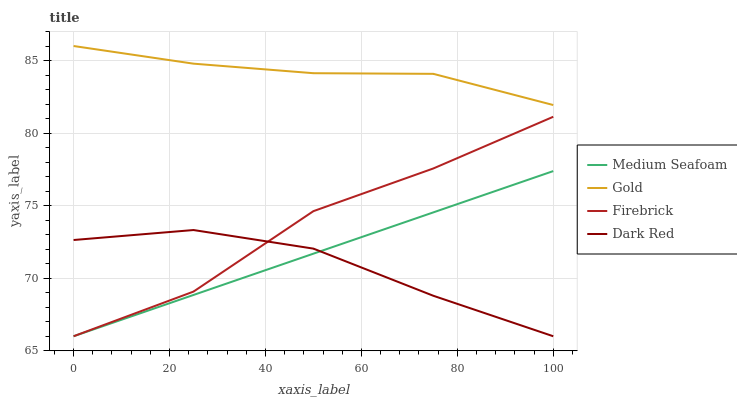Does Dark Red have the minimum area under the curve?
Answer yes or no. Yes. Does Gold have the maximum area under the curve?
Answer yes or no. Yes. Does Firebrick have the minimum area under the curve?
Answer yes or no. No. Does Firebrick have the maximum area under the curve?
Answer yes or no. No. Is Medium Seafoam the smoothest?
Answer yes or no. Yes. Is Firebrick the roughest?
Answer yes or no. Yes. Is Firebrick the smoothest?
Answer yes or no. No. Is Medium Seafoam the roughest?
Answer yes or no. No. Does Dark Red have the lowest value?
Answer yes or no. Yes. Does Gold have the lowest value?
Answer yes or no. No. Does Gold have the highest value?
Answer yes or no. Yes. Does Firebrick have the highest value?
Answer yes or no. No. Is Medium Seafoam less than Gold?
Answer yes or no. Yes. Is Gold greater than Firebrick?
Answer yes or no. Yes. Does Firebrick intersect Medium Seafoam?
Answer yes or no. Yes. Is Firebrick less than Medium Seafoam?
Answer yes or no. No. Is Firebrick greater than Medium Seafoam?
Answer yes or no. No. Does Medium Seafoam intersect Gold?
Answer yes or no. No. 